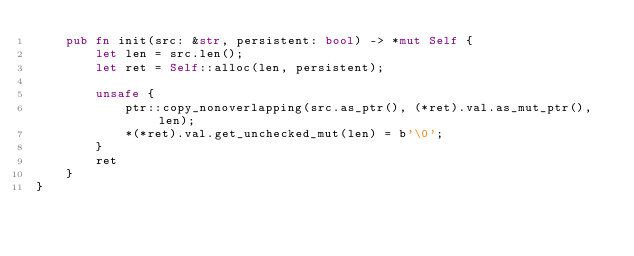<code> <loc_0><loc_0><loc_500><loc_500><_Rust_>    pub fn init(src: &str, persistent: bool) -> *mut Self {
        let len = src.len();
        let ret = Self::alloc(len, persistent);

        unsafe {
            ptr::copy_nonoverlapping(src.as_ptr(), (*ret).val.as_mut_ptr(), len);
            *(*ret).val.get_unchecked_mut(len) = b'\0';
        }
        ret
    }
}</code> 